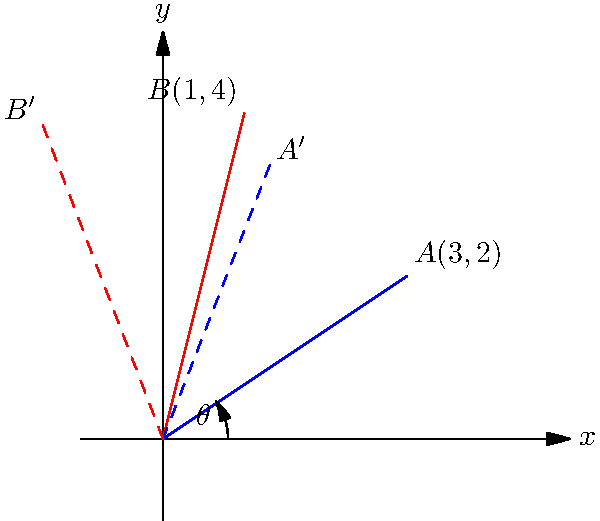In a genetic mapping study, two genetic markers A and B are initially located at coordinates (3,2) and (1,4) respectively. To align with a specific orientation, the coordinate system needs to be rotated by 35°. What are the new coordinates of marker B after this rotation? Round your answer to two decimal places. To solve this problem, we need to use the rotation matrix for a counterclockwise rotation by angle $\theta$:

$$
R(\theta) = \begin{pmatrix}
\cos\theta & -\sin\theta \\
\sin\theta & \cos\theta
\end{pmatrix}
$$

Given:
- Initial coordinates of marker B: $(1,4)$
- Rotation angle: $\theta = 35°$

Steps:
1) Convert the angle to radians: $35° \times \frac{\pi}{180°} = \frac{35\pi}{180}$ radians

2) Calculate $\cos\theta$ and $\sin\theta$:
   $\cos\theta \approx 0.8192$
   $\sin\theta \approx 0.5736$

3) Apply the rotation matrix:
   $$
   \begin{pmatrix}
   x' \\
   y'
   \end{pmatrix} = 
   \begin{pmatrix}
   \cos\theta & -\sin\theta \\
   \sin\theta & \cos\theta
   \end{pmatrix}
   \begin{pmatrix}
   x \\
   y
   \end{pmatrix}
   $$

   $$
   \begin{pmatrix}
   x' \\
   y'
   \end{pmatrix} = 
   \begin{pmatrix}
   0.8192 & -0.5736 \\
   0.5736 & 0.8192
   \end{pmatrix}
   \begin{pmatrix}
   1 \\
   4
   \end{pmatrix}
   $$

4) Multiply the matrices:
   $x' = (0.8192 \times 1) + (-0.5736 \times 4) = -1.4752$
   $y' = (0.5736 \times 1) + (0.8192 \times 4) = 3.8504$

5) Round to two decimal places:
   $x' \approx -1.48$
   $y' \approx 3.85$

Therefore, the new coordinates of marker B after rotation are approximately (-1.48, 3.85).
Answer: (-1.48, 3.85) 